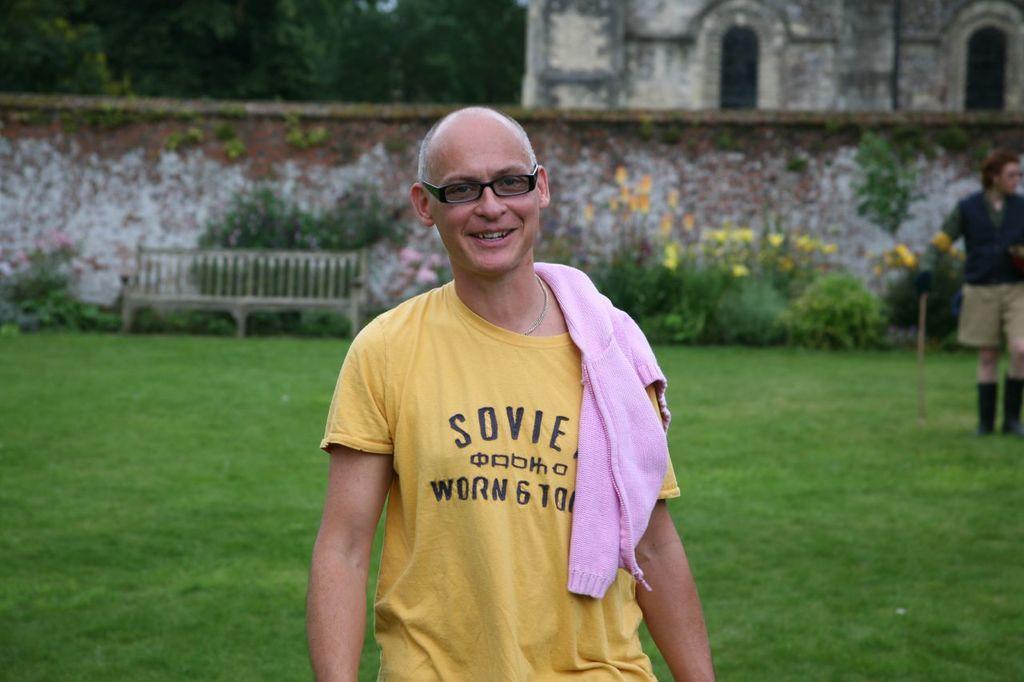Could you give a brief overview of what you see in this image? In the center of the image there is a person wearing a yellow color t-shirt. In the background of the image there is a house. There are trees. There is wall. There is a bench. To the right side of the image there is a person standing and holding a stick. At the bottom of the image there is grass. 